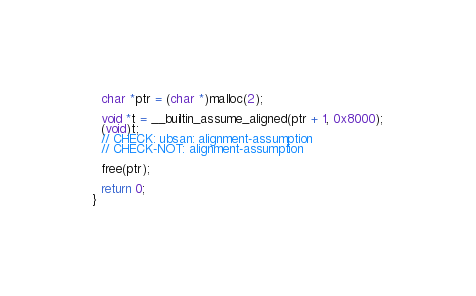Convert code to text. <code><loc_0><loc_0><loc_500><loc_500><_C_>
  char *ptr = (char *)malloc(2);

  void *t = __builtin_assume_aligned(ptr + 1, 0x8000);
  (void)t;
  // CHECK: ubsan: alignment-assumption
  // CHECK-NOT: alignment-assumption

  free(ptr);

  return 0;
}
</code> 